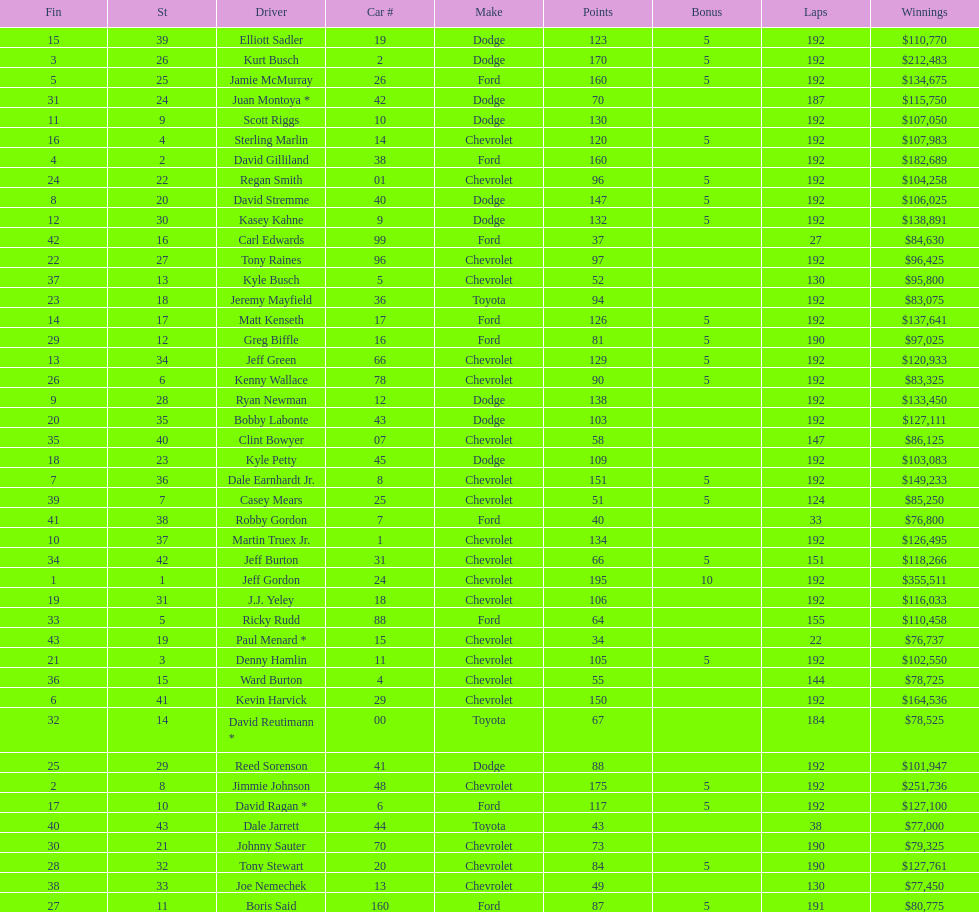Write the full table. {'header': ['Fin', 'St', 'Driver', 'Car #', 'Make', 'Points', 'Bonus', 'Laps', 'Winnings'], 'rows': [['15', '39', 'Elliott Sadler', '19', 'Dodge', '123', '5', '192', '$110,770'], ['3', '26', 'Kurt Busch', '2', 'Dodge', '170', '5', '192', '$212,483'], ['5', '25', 'Jamie McMurray', '26', 'Ford', '160', '5', '192', '$134,675'], ['31', '24', 'Juan Montoya *', '42', 'Dodge', '70', '', '187', '$115,750'], ['11', '9', 'Scott Riggs', '10', 'Dodge', '130', '', '192', '$107,050'], ['16', '4', 'Sterling Marlin', '14', 'Chevrolet', '120', '5', '192', '$107,983'], ['4', '2', 'David Gilliland', '38', 'Ford', '160', '', '192', '$182,689'], ['24', '22', 'Regan Smith', '01', 'Chevrolet', '96', '5', '192', '$104,258'], ['8', '20', 'David Stremme', '40', 'Dodge', '147', '5', '192', '$106,025'], ['12', '30', 'Kasey Kahne', '9', 'Dodge', '132', '5', '192', '$138,891'], ['42', '16', 'Carl Edwards', '99', 'Ford', '37', '', '27', '$84,630'], ['22', '27', 'Tony Raines', '96', 'Chevrolet', '97', '', '192', '$96,425'], ['37', '13', 'Kyle Busch', '5', 'Chevrolet', '52', '', '130', '$95,800'], ['23', '18', 'Jeremy Mayfield', '36', 'Toyota', '94', '', '192', '$83,075'], ['14', '17', 'Matt Kenseth', '17', 'Ford', '126', '5', '192', '$137,641'], ['29', '12', 'Greg Biffle', '16', 'Ford', '81', '5', '190', '$97,025'], ['13', '34', 'Jeff Green', '66', 'Chevrolet', '129', '5', '192', '$120,933'], ['26', '6', 'Kenny Wallace', '78', 'Chevrolet', '90', '5', '192', '$83,325'], ['9', '28', 'Ryan Newman', '12', 'Dodge', '138', '', '192', '$133,450'], ['20', '35', 'Bobby Labonte', '43', 'Dodge', '103', '', '192', '$127,111'], ['35', '40', 'Clint Bowyer', '07', 'Chevrolet', '58', '', '147', '$86,125'], ['18', '23', 'Kyle Petty', '45', 'Dodge', '109', '', '192', '$103,083'], ['7', '36', 'Dale Earnhardt Jr.', '8', 'Chevrolet', '151', '5', '192', '$149,233'], ['39', '7', 'Casey Mears', '25', 'Chevrolet', '51', '5', '124', '$85,250'], ['41', '38', 'Robby Gordon', '7', 'Ford', '40', '', '33', '$76,800'], ['10', '37', 'Martin Truex Jr.', '1', 'Chevrolet', '134', '', '192', '$126,495'], ['34', '42', 'Jeff Burton', '31', 'Chevrolet', '66', '5', '151', '$118,266'], ['1', '1', 'Jeff Gordon', '24', 'Chevrolet', '195', '10', '192', '$355,511'], ['19', '31', 'J.J. Yeley', '18', 'Chevrolet', '106', '', '192', '$116,033'], ['33', '5', 'Ricky Rudd', '88', 'Ford', '64', '', '155', '$110,458'], ['43', '19', 'Paul Menard *', '15', 'Chevrolet', '34', '', '22', '$76,737'], ['21', '3', 'Denny Hamlin', '11', 'Chevrolet', '105', '5', '192', '$102,550'], ['36', '15', 'Ward Burton', '4', 'Chevrolet', '55', '', '144', '$78,725'], ['6', '41', 'Kevin Harvick', '29', 'Chevrolet', '150', '', '192', '$164,536'], ['32', '14', 'David Reutimann *', '00', 'Toyota', '67', '', '184', '$78,525'], ['25', '29', 'Reed Sorenson', '41', 'Dodge', '88', '', '192', '$101,947'], ['2', '8', 'Jimmie Johnson', '48', 'Chevrolet', '175', '5', '192', '$251,736'], ['17', '10', 'David Ragan *', '6', 'Ford', '117', '5', '192', '$127,100'], ['40', '43', 'Dale Jarrett', '44', 'Toyota', '43', '', '38', '$77,000'], ['30', '21', 'Johnny Sauter', '70', 'Chevrolet', '73', '', '190', '$79,325'], ['28', '32', 'Tony Stewart', '20', 'Chevrolet', '84', '5', '190', '$127,761'], ['38', '33', 'Joe Nemechek', '13', 'Chevrolet', '49', '', '130', '$77,450'], ['27', '11', 'Boris Said', '160', 'Ford', '87', '5', '191', '$80,775']]} What driver earned the least amount of winnings? Paul Menard *. 